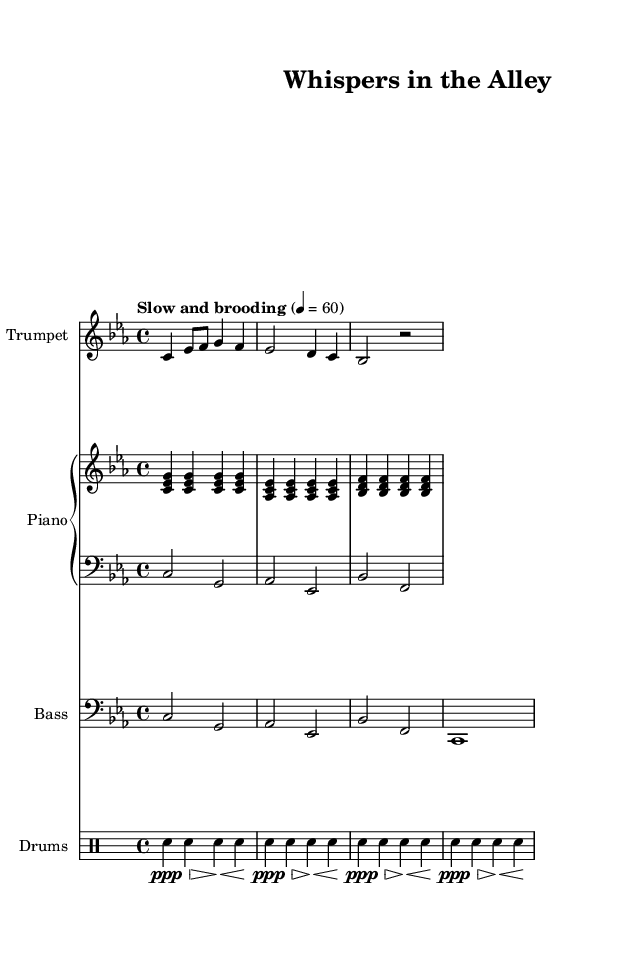What is the key signature of this music? The key signature is indicated at the beginning of the score and shows C minor, which has three flats (B-flat, E-flat, A-flat).
Answer: C minor What is the time signature of this piece? The time signature is found at the beginning of the sheet music, showing 4/4, meaning there are four beats in each measure.
Answer: 4/4 What tempo marking is given for the music? The tempo marking is stated in words at the beginning, indicating a slow and brooding pace, set at a quarter note equals 60 beats per minute.
Answer: Slow and brooding How many measures are in the trumpet melody? The trumpet melody consists of four lines of music, with each line containing two measures, making a total of eight measures.
Answer: Eight measures Which instruments are included in this score? The score lists a trumpet, piano (with both right and left hands), bass, and drums, which are common in jazz ensembles and soundtracks.
Answer: Trumpet, piano, bass, drums What is the function of the drum pattern in this piece? The drum pattern adds rhythm and atmosphere, using soft snare hits that help establish the mood of the piece, typical for noir-inspired soundtracks.
Answer: Establishes mood What is the common chord progression used in the piano? The piano voicings suggest a progression often found in jazz, alternating between the tonic (C minor) and dominant seventh chords (G7), creating tension and resolution.
Answer: C minor to G7 